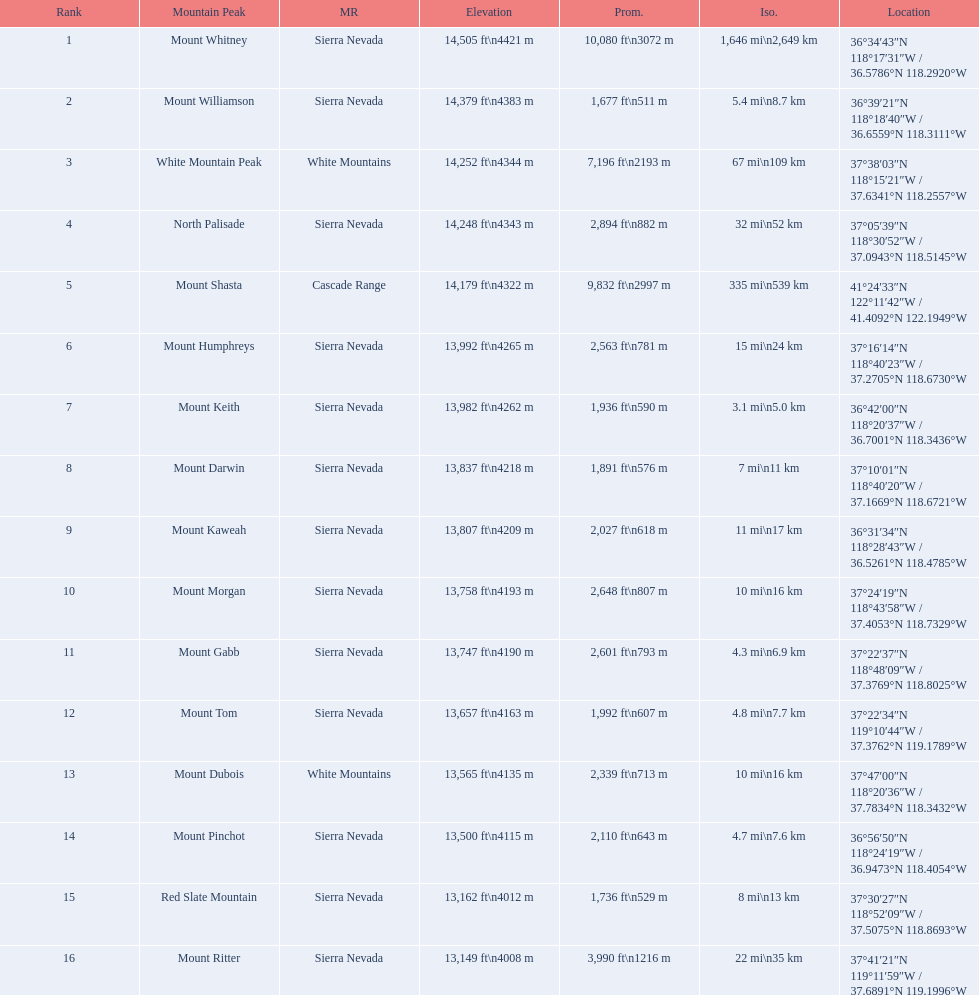What are the prominence lengths higher than 10,000 feet? 10,080 ft\n3072 m. What mountain peak has a prominence of 10,080 feet? Mount Whitney. 